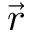Convert formula to latex. <formula><loc_0><loc_0><loc_500><loc_500>\vec { r }</formula> 